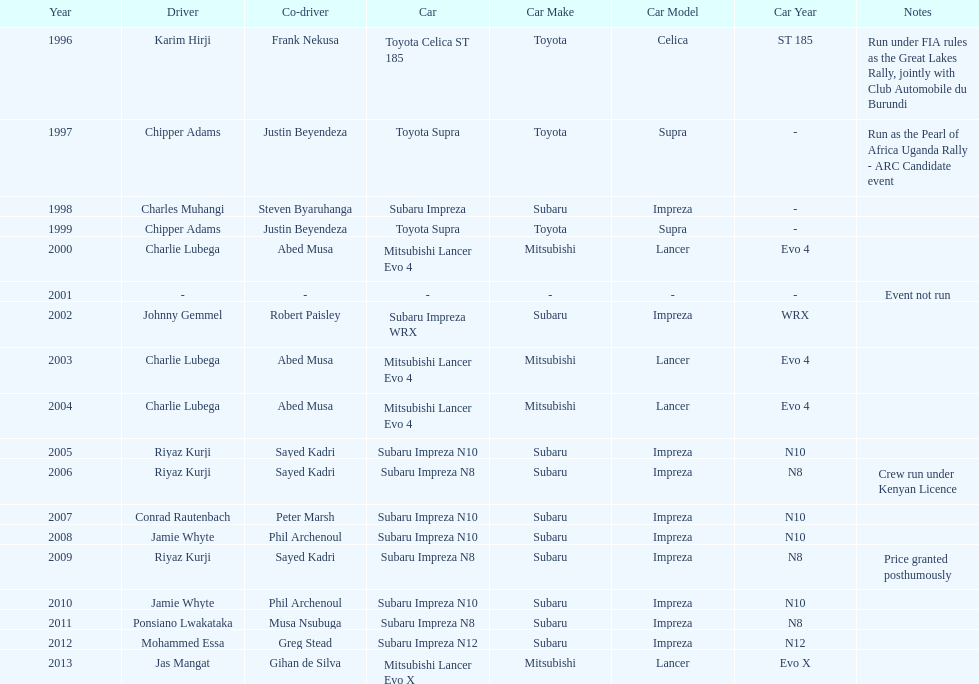Are there more than three wins for chipper adams and justin beyendeza? No. Could you parse the entire table as a dict? {'header': ['Year', 'Driver', 'Co-driver', 'Car', 'Car Make', 'Car Model', 'Car Year', 'Notes'], 'rows': [['1996', 'Karim Hirji', 'Frank Nekusa', 'Toyota Celica ST 185', 'Toyota', 'Celica', 'ST 185', 'Run under FIA rules as the Great Lakes Rally, jointly with Club Automobile du Burundi'], ['1997', 'Chipper Adams', 'Justin Beyendeza', 'Toyota Supra', 'Toyota', 'Supra', '-', 'Run as the Pearl of Africa Uganda Rally - ARC Candidate event'], ['1998', 'Charles Muhangi', 'Steven Byaruhanga', 'Subaru Impreza', 'Subaru', 'Impreza', '-', ''], ['1999', 'Chipper Adams', 'Justin Beyendeza', 'Toyota Supra', 'Toyota', 'Supra', '-', ''], ['2000', 'Charlie Lubega', 'Abed Musa', 'Mitsubishi Lancer Evo 4', 'Mitsubishi', 'Lancer', 'Evo 4', ''], ['2001', '-', '-', '-', '-', '-', '-', 'Event not run'], ['2002', 'Johnny Gemmel', 'Robert Paisley', 'Subaru Impreza WRX', 'Subaru', 'Impreza', 'WRX', ''], ['2003', 'Charlie Lubega', 'Abed Musa', 'Mitsubishi Lancer Evo 4', 'Mitsubishi', 'Lancer', 'Evo 4', ''], ['2004', 'Charlie Lubega', 'Abed Musa', 'Mitsubishi Lancer Evo 4', 'Mitsubishi', 'Lancer', 'Evo 4', ''], ['2005', 'Riyaz Kurji', 'Sayed Kadri', 'Subaru Impreza N10', 'Subaru', 'Impreza', 'N10', ''], ['2006', 'Riyaz Kurji', 'Sayed Kadri', 'Subaru Impreza N8', 'Subaru', 'Impreza', 'N8', 'Crew run under Kenyan Licence'], ['2007', 'Conrad Rautenbach', 'Peter Marsh', 'Subaru Impreza N10', 'Subaru', 'Impreza', 'N10', ''], ['2008', 'Jamie Whyte', 'Phil Archenoul', 'Subaru Impreza N10', 'Subaru', 'Impreza', 'N10', ''], ['2009', 'Riyaz Kurji', 'Sayed Kadri', 'Subaru Impreza N8', 'Subaru', 'Impreza', 'N8', 'Price granted posthumously'], ['2010', 'Jamie Whyte', 'Phil Archenoul', 'Subaru Impreza N10', 'Subaru', 'Impreza', 'N10', ''], ['2011', 'Ponsiano Lwakataka', 'Musa Nsubuga', 'Subaru Impreza N8', 'Subaru', 'Impreza', 'N8', ''], ['2012', 'Mohammed Essa', 'Greg Stead', 'Subaru Impreza N12', 'Subaru', 'Impreza', 'N12', ''], ['2013', 'Jas Mangat', 'Gihan de Silva', 'Mitsubishi Lancer Evo X', 'Mitsubishi', 'Lancer', 'Evo X', '']]} 